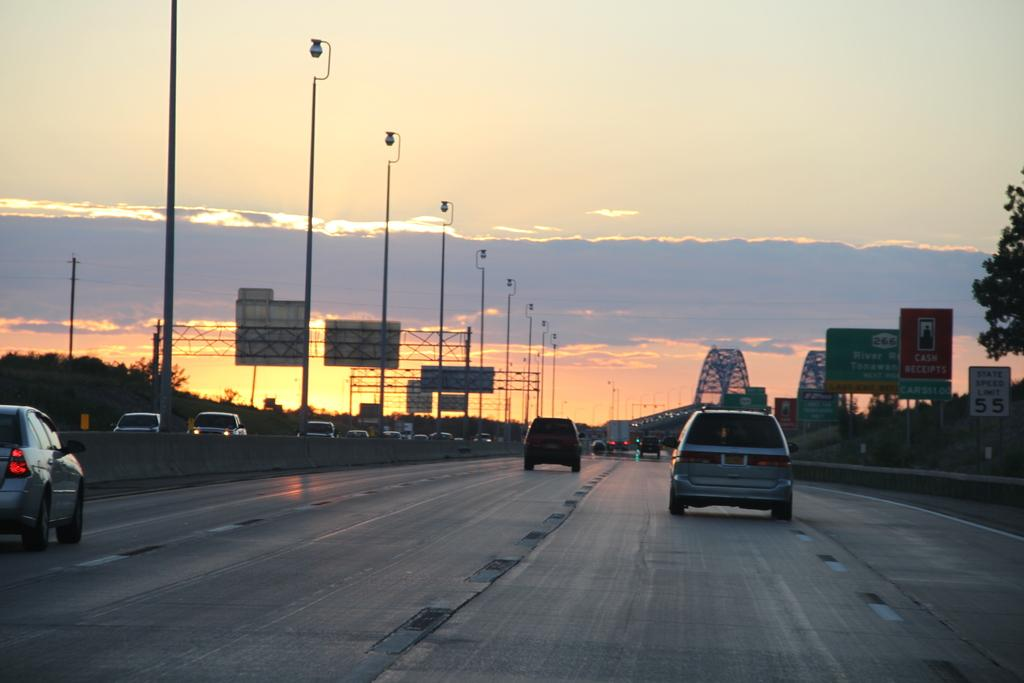What is happening on the road in the image? There are vehicles moving on the road in the image. What can be seen on the right side of the image? There are boards and trees on the right side of the image. What is visible at the top of the image? The sky is visible at the top of the image. Is there an amusement park visible in the image? No, there is no amusement park present in the image. What type of cap is being worn by the trees on the right side of the image? There are no caps on the trees in the image; they are simply trees. 